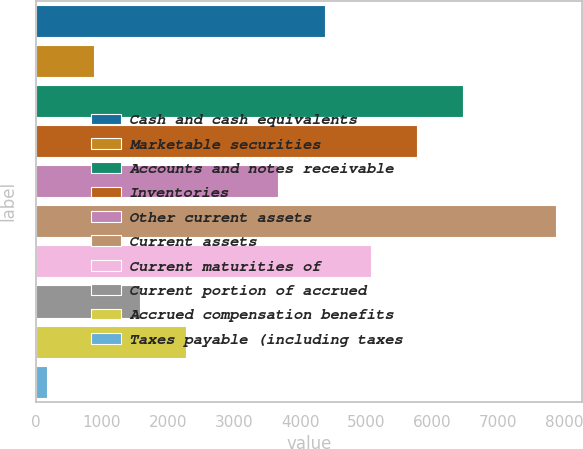Convert chart. <chart><loc_0><loc_0><loc_500><loc_500><bar_chart><fcel>Cash and cash equivalents<fcel>Marketable securities<fcel>Accounts and notes receivable<fcel>Inventories<fcel>Other current assets<fcel>Current assets<fcel>Current maturities of<fcel>Current portion of accrued<fcel>Accrued compensation benefits<fcel>Taxes payable (including taxes<nl><fcel>4369.4<fcel>872.4<fcel>6467.6<fcel>5768.2<fcel>3670<fcel>7866.4<fcel>5068.8<fcel>1571.8<fcel>2271.2<fcel>173<nl></chart> 